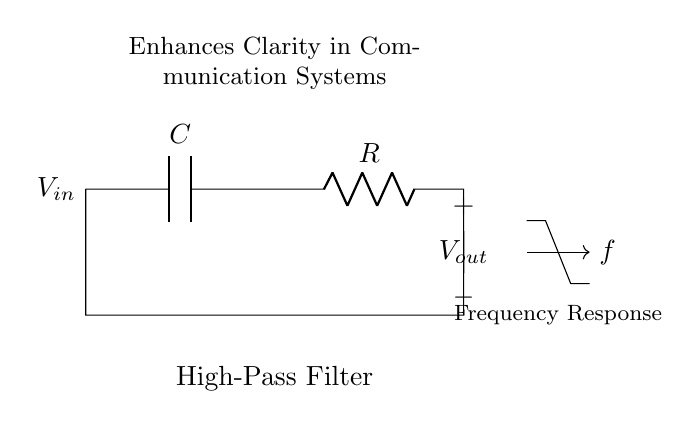What components are used in this high-pass filter? The circuit diagram shows a capacitor and a resistor connected in series, which are the basic components used to construct a high-pass filter.
Answer: Capacitor and Resistor What is the output voltage in this circuit diagram? The output voltage is indicated at the node connected to the resistor, where it is labeled as Vout.
Answer: Vout What is the function of the capacitor in this circuit? The capacitor allows high-frequency signals to pass while blocking low-frequency signals, thus playing a crucial role in establishing the high-pass filter function.
Answer: Allowing high frequencies How does changing the resistor value affect the cutoff frequency? The cutoff frequency of a high-pass filter is inversely related to the resistor value and the capacitor value according to the formula f_c = 1/(2πRC); increasing R will lower the cutoff frequency, thus altering filter performance.
Answer: Decreases cutoff frequency What type of filter is represented by this circuit? The circuit diagram depicts a high-pass filter, which is specifically designed to allow signals above a certain frequency to pass while attenuating those below that frequency.
Answer: High-pass filter 